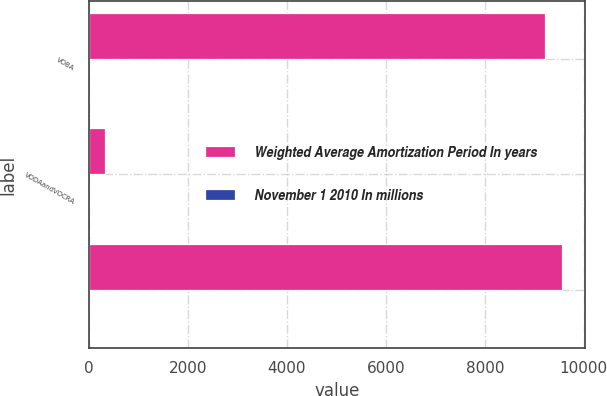<chart> <loc_0><loc_0><loc_500><loc_500><stacked_bar_chart><ecel><fcel>VOBA<fcel>VODAandVOCRA<fcel>Unnamed: 3<nl><fcel>Weighted Average Amortization Period In years<fcel>9210<fcel>341<fcel>9551<nl><fcel>November 1 2010 In millions<fcel>8.2<fcel>10.3<fcel>8.6<nl></chart> 